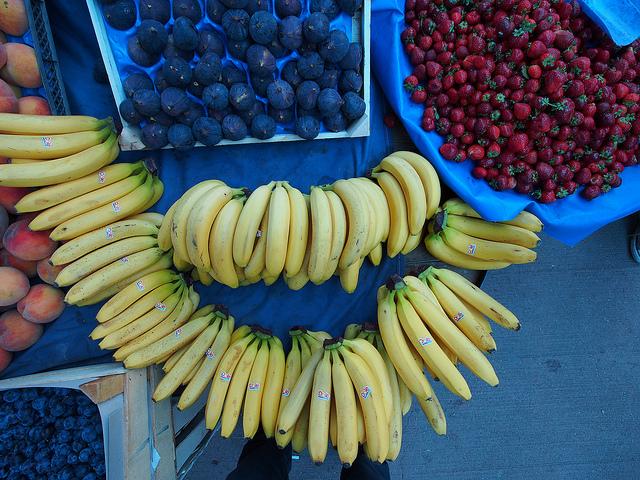Do all the bananas have the same color?
Keep it brief. Yes. What fruits are on the right?
Be succinct. Strawberries. How many different food products are there?
Quick response, please. 5. What brand are the yellow fruit?
Quick response, please. Dole. 